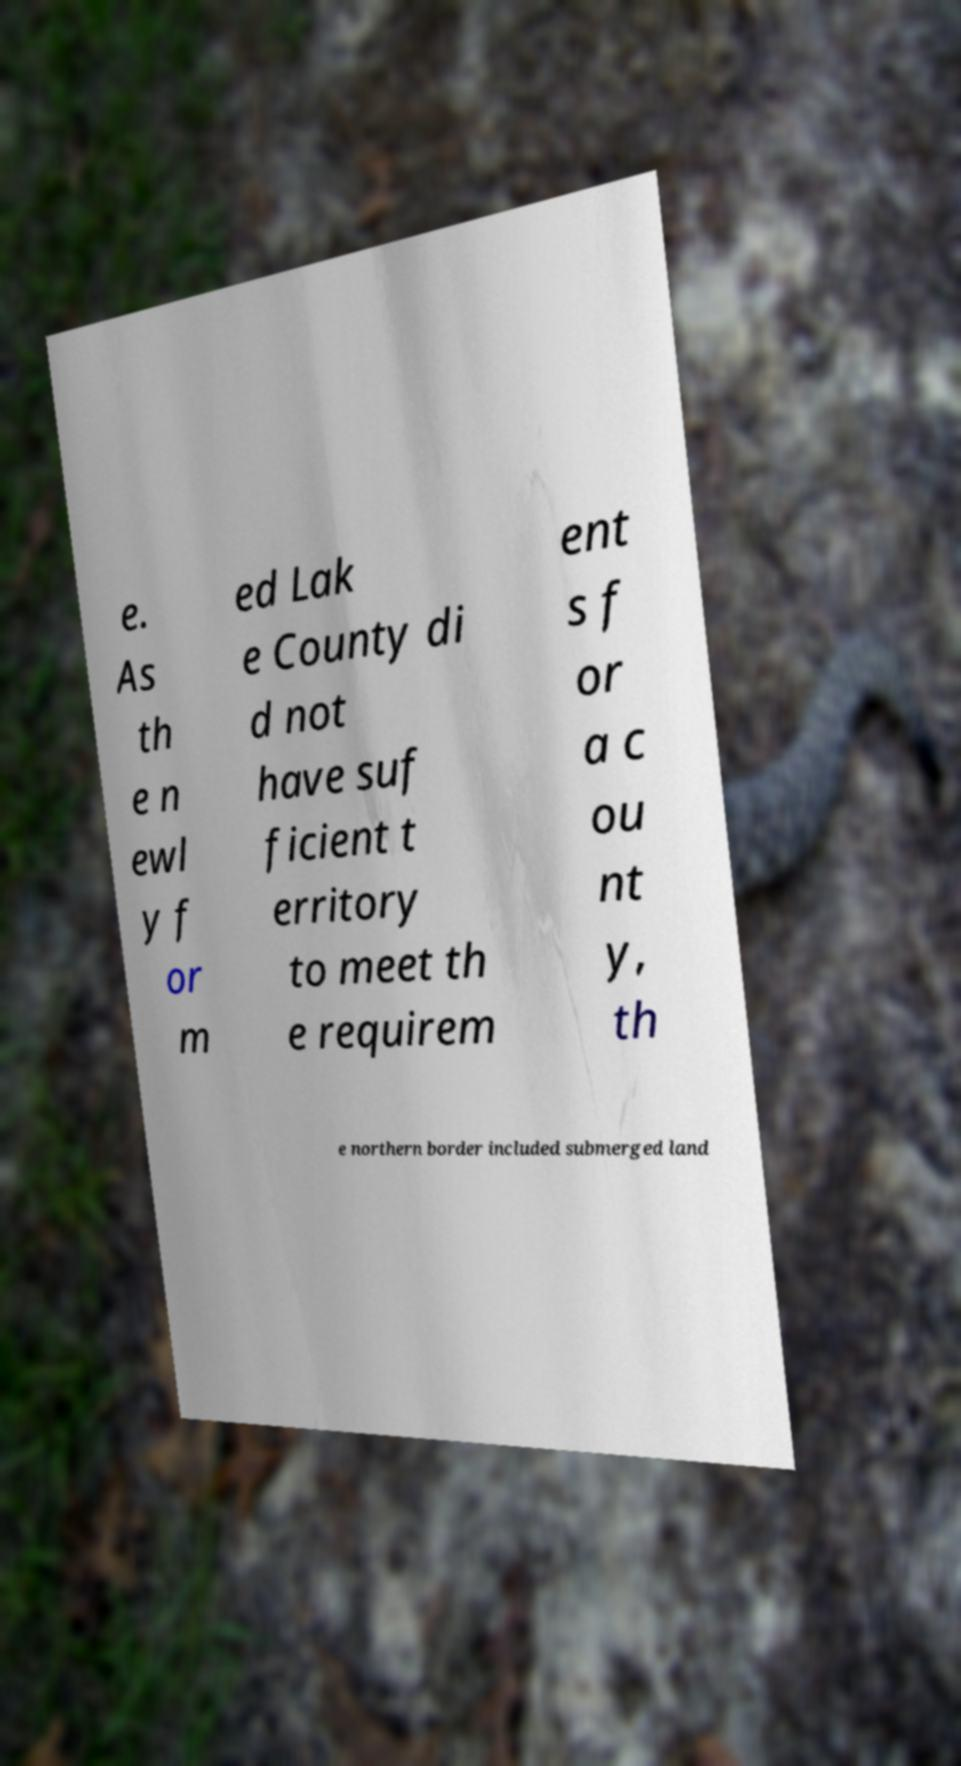I need the written content from this picture converted into text. Can you do that? e. As th e n ewl y f or m ed Lak e County di d not have suf ficient t erritory to meet th e requirem ent s f or a c ou nt y, th e northern border included submerged land 